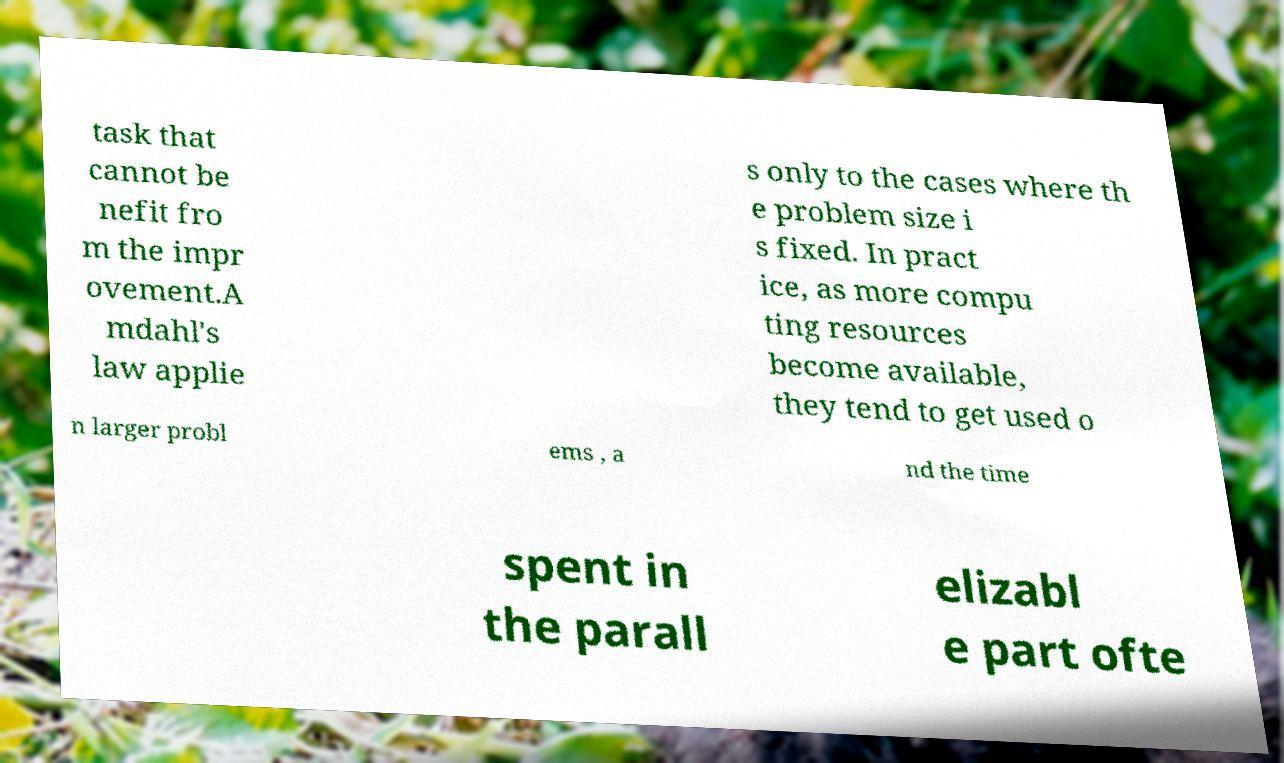I need the written content from this picture converted into text. Can you do that? task that cannot be nefit fro m the impr ovement.A mdahl's law applie s only to the cases where th e problem size i s fixed. In pract ice, as more compu ting resources become available, they tend to get used o n larger probl ems , a nd the time spent in the parall elizabl e part ofte 